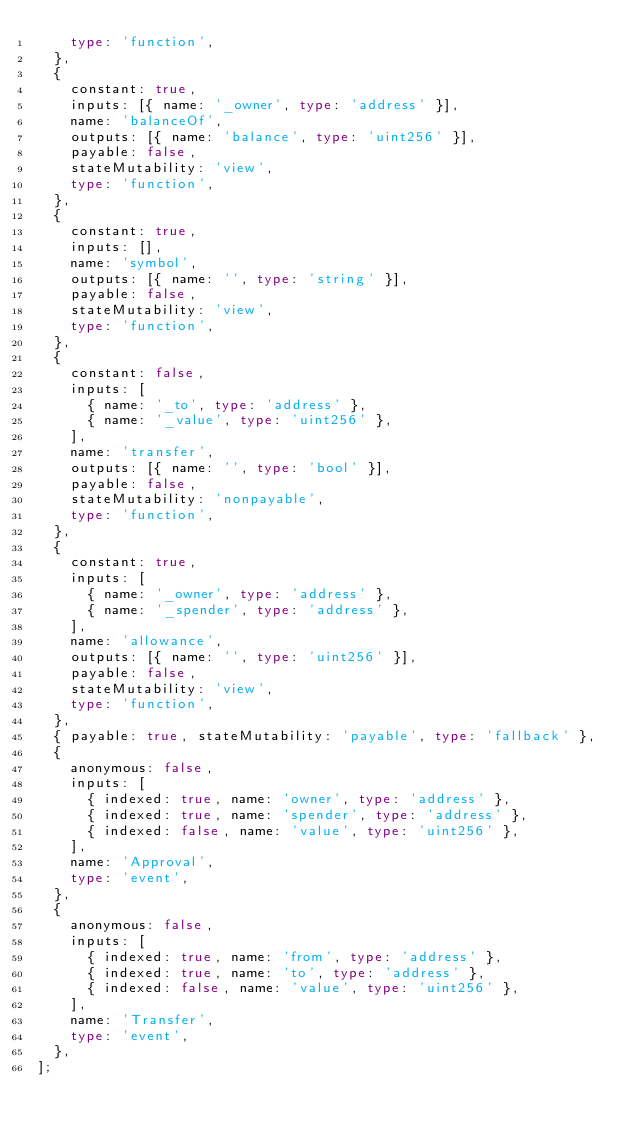Convert code to text. <code><loc_0><loc_0><loc_500><loc_500><_TypeScript_>    type: 'function',
  },
  {
    constant: true,
    inputs: [{ name: '_owner', type: 'address' }],
    name: 'balanceOf',
    outputs: [{ name: 'balance', type: 'uint256' }],
    payable: false,
    stateMutability: 'view',
    type: 'function',
  },
  {
    constant: true,
    inputs: [],
    name: 'symbol',
    outputs: [{ name: '', type: 'string' }],
    payable: false,
    stateMutability: 'view',
    type: 'function',
  },
  {
    constant: false,
    inputs: [
      { name: '_to', type: 'address' },
      { name: '_value', type: 'uint256' },
    ],
    name: 'transfer',
    outputs: [{ name: '', type: 'bool' }],
    payable: false,
    stateMutability: 'nonpayable',
    type: 'function',
  },
  {
    constant: true,
    inputs: [
      { name: '_owner', type: 'address' },
      { name: '_spender', type: 'address' },
    ],
    name: 'allowance',
    outputs: [{ name: '', type: 'uint256' }],
    payable: false,
    stateMutability: 'view',
    type: 'function',
  },
  { payable: true, stateMutability: 'payable', type: 'fallback' },
  {
    anonymous: false,
    inputs: [
      { indexed: true, name: 'owner', type: 'address' },
      { indexed: true, name: 'spender', type: 'address' },
      { indexed: false, name: 'value', type: 'uint256' },
    ],
    name: 'Approval',
    type: 'event',
  },
  {
    anonymous: false,
    inputs: [
      { indexed: true, name: 'from', type: 'address' },
      { indexed: true, name: 'to', type: 'address' },
      { indexed: false, name: 'value', type: 'uint256' },
    ],
    name: 'Transfer',
    type: 'event',
  },
];
</code> 